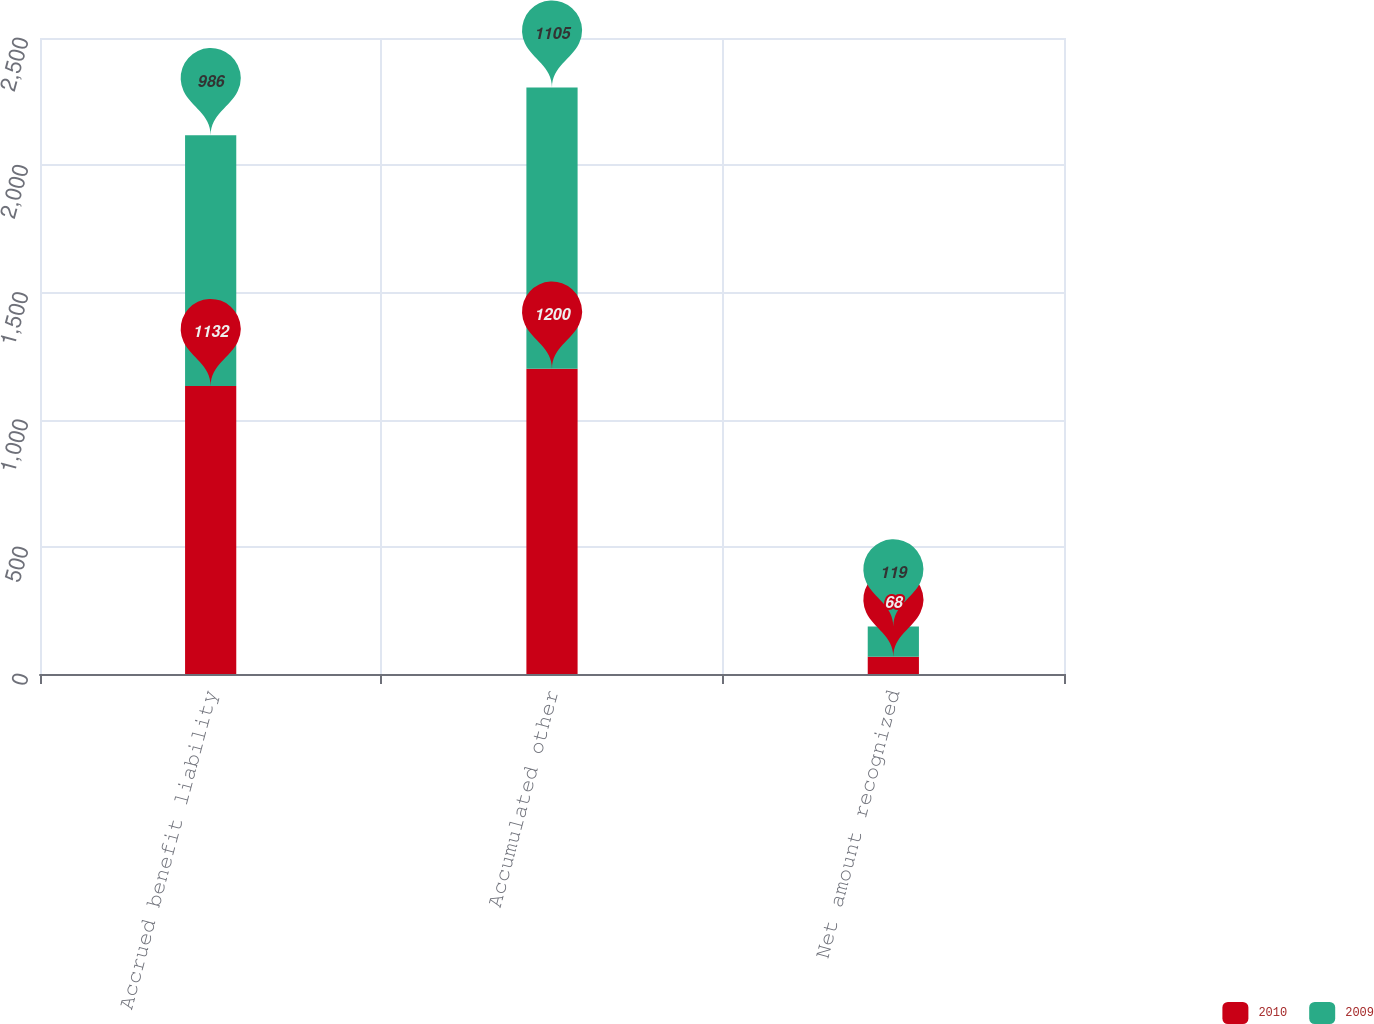<chart> <loc_0><loc_0><loc_500><loc_500><stacked_bar_chart><ecel><fcel>Accrued benefit liability<fcel>Accumulated other<fcel>Net amount recognized<nl><fcel>2010<fcel>1132<fcel>1200<fcel>68<nl><fcel>2009<fcel>986<fcel>1105<fcel>119<nl></chart> 